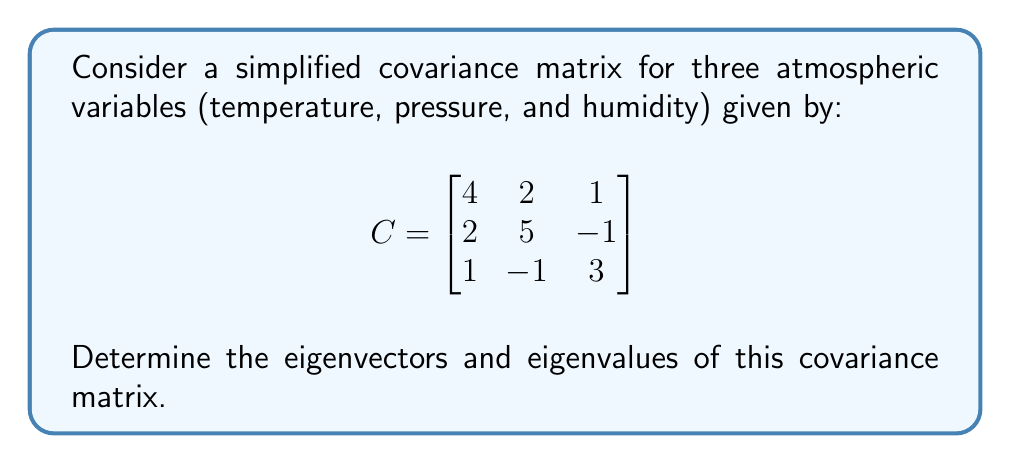Show me your answer to this math problem. To find the eigenvectors and eigenvalues of the covariance matrix C, we follow these steps:

1) First, we need to solve the characteristic equation:
   $\det(C - \lambda I) = 0$

2) Expand the determinant:
   $$\begin{vmatrix}
   4-\lambda & 2 & 1 \\
   2 & 5-\lambda & -1 \\
   1 & -1 & 3-\lambda
   \end{vmatrix} = 0$$

3) Calculate the determinant:
   $(4-\lambda)[(5-\lambda)(3-\lambda)+1] - 2[2(3-\lambda)-1] + 1[2(-1)-(5-\lambda)] = 0$

4) Simplify:
   $\lambda^3 - 12\lambda^2 + 41\lambda - 40 = 0$

5) Solve this cubic equation. The solutions are the eigenvalues:
   $\lambda_1 = 2$, $\lambda_2 = 4$, $\lambda_3 = 6$

6) For each eigenvalue, solve $(C - \lambda I)v = 0$ to find the corresponding eigenvector:

   For $\lambda_1 = 2$:
   $$\begin{bmatrix}
   2 & 2 & 1 \\
   2 & 3 & -1 \\
   1 & -1 & 1
   \end{bmatrix}v = 0$$
   Solving this gives $v_1 = (1, -1, 1)^T$

   For $\lambda_2 = 4$:
   $$\begin{bmatrix}
   0 & 2 & 1 \\
   2 & 1 & -1 \\
   1 & -1 & -1
   \end{bmatrix}v = 0$$
   Solving this gives $v_2 = (1, 1, 2)^T$

   For $\lambda_3 = 6$:
   $$\begin{bmatrix}
   -2 & 2 & 1 \\
   2 & -1 & -1 \\
   1 & -1 & -3
   \end{bmatrix}v = 0$$
   Solving this gives $v_3 = (2, 2, -1)^T$

7) Normalize the eigenvectors:
   $v_1 = (\frac{1}{\sqrt{3}}, -\frac{1}{\sqrt{3}}, \frac{1}{\sqrt{3}})^T$
   $v_2 = (\frac{1}{\sqrt{6}}, \frac{1}{\sqrt{6}}, \frac{2}{\sqrt{6}})^T$
   $v_3 = (\frac{2}{\sqrt{9}}, \frac{2}{\sqrt{9}}, -\frac{1}{\sqrt{9}})^T$
Answer: Eigenvalues: $\lambda_1 = 2$, $\lambda_2 = 4$, $\lambda_3 = 6$
Normalized eigenvectors: $v_1 = (\frac{1}{\sqrt{3}}, -\frac{1}{\sqrt{3}}, \frac{1}{\sqrt{3}})^T$, $v_2 = (\frac{1}{\sqrt{6}}, \frac{1}{\sqrt{6}}, \frac{2}{\sqrt{6}})^T$, $v_3 = (\frac{2}{\sqrt{9}}, \frac{2}{\sqrt{9}}, -\frac{1}{\sqrt{9}})^T$ 